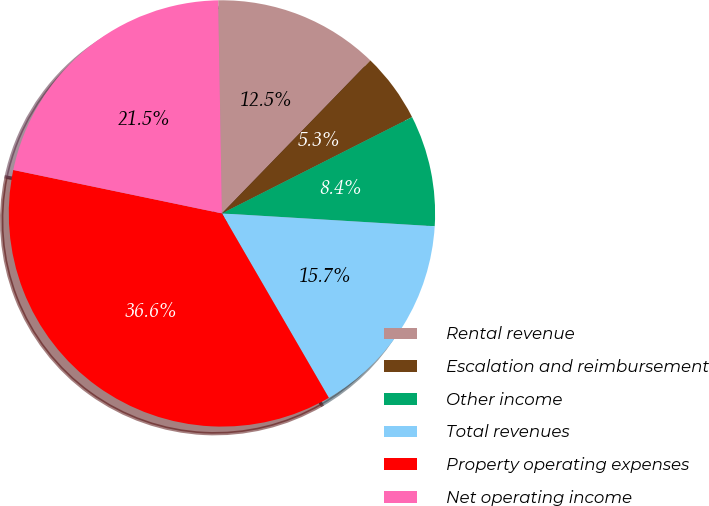Convert chart. <chart><loc_0><loc_0><loc_500><loc_500><pie_chart><fcel>Rental revenue<fcel>Escalation and reimbursement<fcel>Other income<fcel>Total revenues<fcel>Property operating expenses<fcel>Net operating income<nl><fcel>12.54%<fcel>5.28%<fcel>8.42%<fcel>15.68%<fcel>36.63%<fcel>21.45%<nl></chart> 